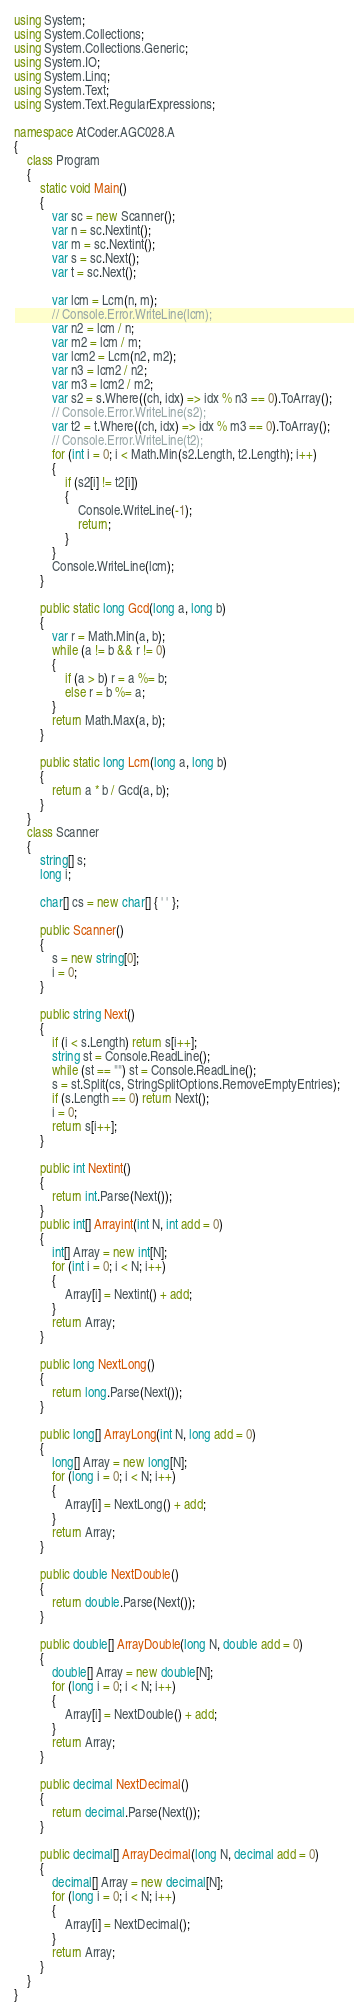<code> <loc_0><loc_0><loc_500><loc_500><_C#_>using System;
using System.Collections;
using System.Collections.Generic;
using System.IO;
using System.Linq;
using System.Text;
using System.Text.RegularExpressions;

namespace AtCoder.AGC028.A
{
    class Program
    {
        static void Main()
        {
            var sc = new Scanner();
            var n = sc.Nextint();
            var m = sc.Nextint();
            var s = sc.Next();
            var t = sc.Next();

            var lcm = Lcm(n, m);
            // Console.Error.WriteLine(lcm);
            var n2 = lcm / n;
            var m2 = lcm / m;
            var lcm2 = Lcm(n2, m2);
            var n3 = lcm2 / n2;
            var m3 = lcm2 / m2;
            var s2 = s.Where((ch, idx) => idx % n3 == 0).ToArray();
            // Console.Error.WriteLine(s2);
            var t2 = t.Where((ch, idx) => idx % m3 == 0).ToArray();
            // Console.Error.WriteLine(t2);
            for (int i = 0; i < Math.Min(s2.Length, t2.Length); i++)
            {
                if (s2[i] != t2[i])
                {
                    Console.WriteLine(-1);
                    return;
                }
            }
            Console.WriteLine(lcm);
        }

        public static long Gcd(long a, long b)
        {
            var r = Math.Min(a, b);
            while (a != b && r != 0)
            {
                if (a > b) r = a %= b;
                else r = b %= a;
            }
            return Math.Max(a, b);
        }

        public static long Lcm(long a, long b)
        {
            return a * b / Gcd(a, b);
        }
    }
    class Scanner
    {
        string[] s;
        long i;

        char[] cs = new char[] { ' ' };

        public Scanner()
        {
            s = new string[0];
            i = 0;
        }

        public string Next()
        {
            if (i < s.Length) return s[i++];
            string st = Console.ReadLine();
            while (st == "") st = Console.ReadLine();
            s = st.Split(cs, StringSplitOptions.RemoveEmptyEntries);
            if (s.Length == 0) return Next();
            i = 0;
            return s[i++];
        }

        public int Nextint()
        {
            return int.Parse(Next());
        }
        public int[] Arrayint(int N, int add = 0)
        {
            int[] Array = new int[N];
            for (int i = 0; i < N; i++)
            {
                Array[i] = Nextint() + add;
            }
            return Array;
        }

        public long NextLong()
        {
            return long.Parse(Next());
        }

        public long[] ArrayLong(int N, long add = 0)
        {
            long[] Array = new long[N];
            for (long i = 0; i < N; i++)
            {
                Array[i] = NextLong() + add;
            }
            return Array;
        }

        public double NextDouble()
        {
            return double.Parse(Next());
        }

        public double[] ArrayDouble(long N, double add = 0)
        {
            double[] Array = new double[N];
            for (long i = 0; i < N; i++)
            {
                Array[i] = NextDouble() + add;
            }
            return Array;
        }

        public decimal NextDecimal()
        {
            return decimal.Parse(Next());
        }

        public decimal[] ArrayDecimal(long N, decimal add = 0)
        {
            decimal[] Array = new decimal[N];
            for (long i = 0; i < N; i++)
            {
                Array[i] = NextDecimal();
            }
            return Array;
        }
    }
}
</code> 